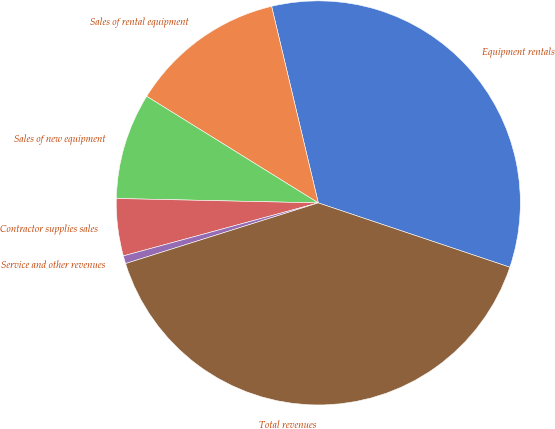Convert chart to OTSL. <chart><loc_0><loc_0><loc_500><loc_500><pie_chart><fcel>Equipment rentals<fcel>Sales of rental equipment<fcel>Sales of new equipment<fcel>Contractor supplies sales<fcel>Service and other revenues<fcel>Total revenues<nl><fcel>33.87%<fcel>12.44%<fcel>8.5%<fcel>4.57%<fcel>0.63%<fcel>39.99%<nl></chart> 